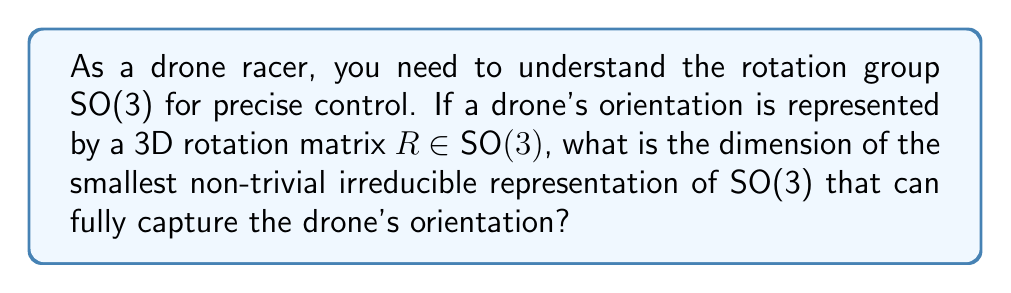Solve this math problem. To solve this problem, let's follow these steps:

1) The group SO(3) represents all possible 3D rotations. For a drone, this describes all possible orientations in 3D space.

2) The irreducible representations of SO(3) are well-known in quantum mechanics and are related to angular momentum. They are usually denoted as $D^j$, where $j$ is a non-negative half-integer.

3) The dimension of the representation $D^j$ is given by $2j+1$.

4) The trivial representation is $D^0$, which has dimension 1. We're asked for the smallest non-trivial representation.

5) The next representation is $D^{\frac{1}{2}}$, but SO(3) doesn't have a double-valued representation, so we skip this.

6) The smallest non-trivial representation for SO(3) is therefore $D^1$.

7) The dimension of $D^1$ is:

   $$\text{dim}(D^1) = 2(1) + 1 = 3$$

8) This 3-dimensional representation corresponds exactly to the natural action of SO(3) on 3D space, which is precisely what we need to describe a drone's orientation.

Therefore, the smallest non-trivial irreducible representation that can fully capture the drone's orientation has dimension 3.
Answer: 3 